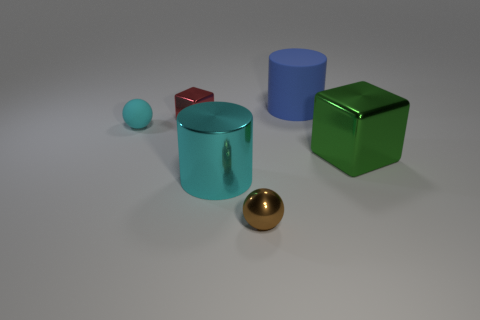Add 1 large cyan metal cylinders. How many objects exist? 7 Subtract all cylinders. How many objects are left? 4 Subtract 0 gray blocks. How many objects are left? 6 Subtract all red cubes. Subtract all blue cylinders. How many cubes are left? 1 Subtract all tiny blocks. Subtract all large blue rubber cylinders. How many objects are left? 4 Add 4 tiny red metal cubes. How many tiny red metal cubes are left? 5 Add 4 small red shiny balls. How many small red shiny balls exist? 4 